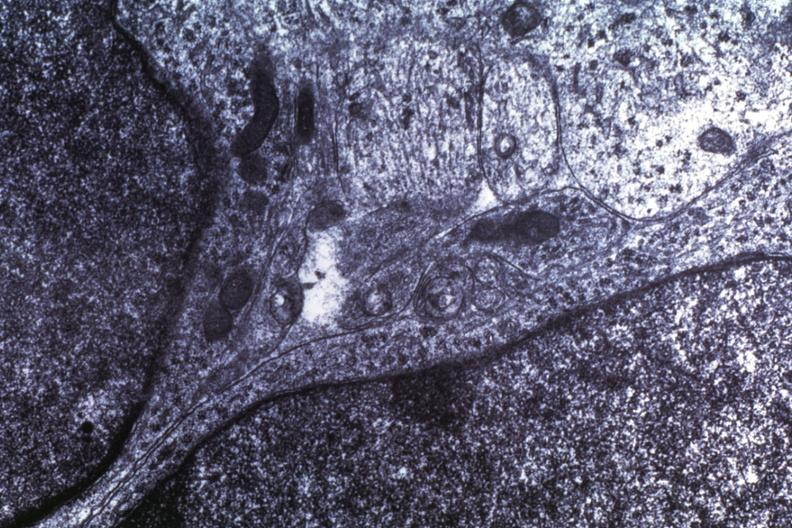does pyelonephritis carcinoma in prostate show dr garcia tumors 64?
Answer the question using a single word or phrase. No 